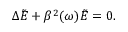Convert formula to latex. <formula><loc_0><loc_0><loc_500><loc_500>\Delta \tilde { E } + \beta ^ { 2 } ( \omega ) \tilde { E } = 0 .</formula> 